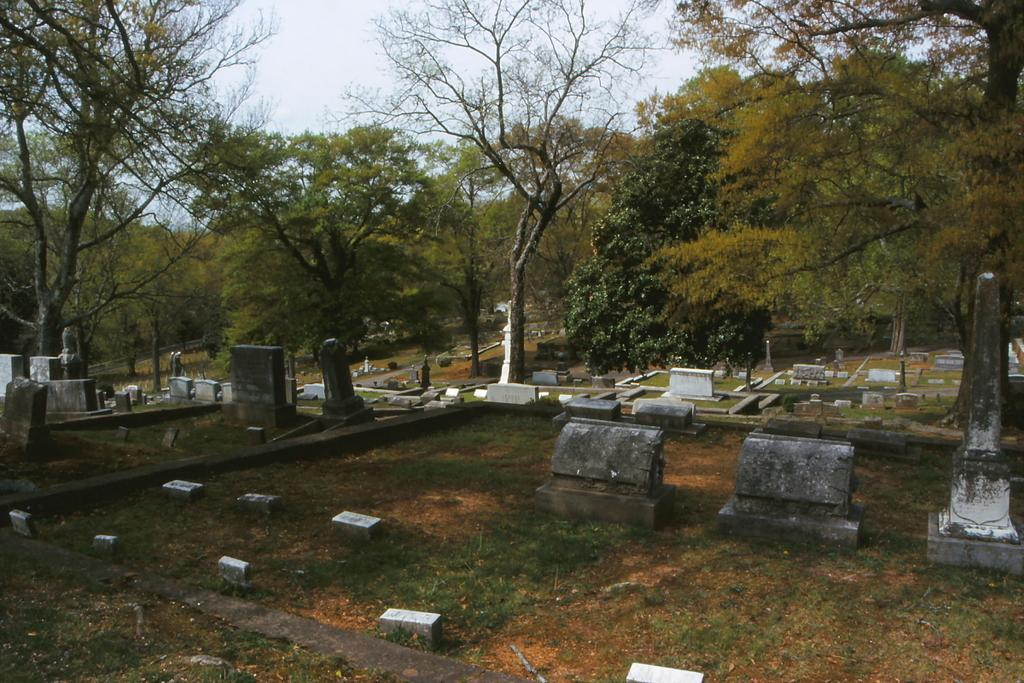What type of structures can be seen in the image? There are grave stones in the image. What type of location is depicted in the image? The location depicted is a graveyard. What type of vegetation is present in the image? There is grass, plants, and trees present in the image. What type of basketball game is taking place in the image? There is no basketball game present in the image. How does the society depicted in the image contribute to the division of the graveyard? The image does not depict a society or any division within the graveyard. 